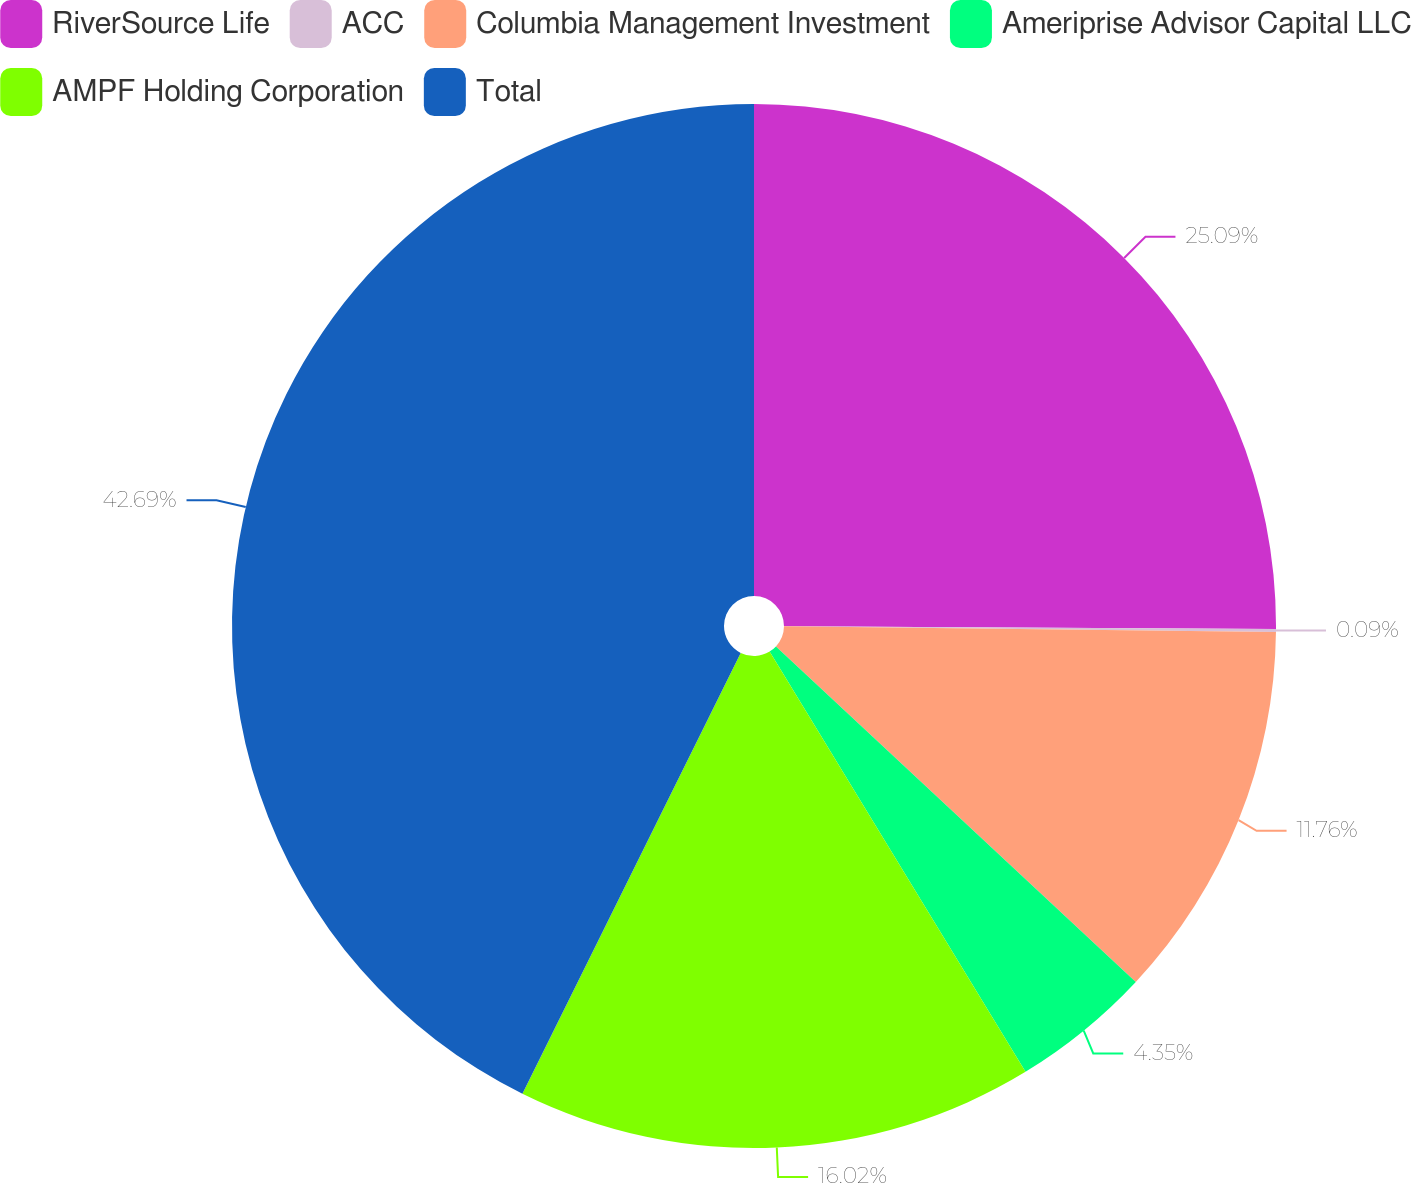Convert chart to OTSL. <chart><loc_0><loc_0><loc_500><loc_500><pie_chart><fcel>RiverSource Life<fcel>ACC<fcel>Columbia Management Investment<fcel>Ameriprise Advisor Capital LLC<fcel>AMPF Holding Corporation<fcel>Total<nl><fcel>25.09%<fcel>0.09%<fcel>11.76%<fcel>4.35%<fcel>16.02%<fcel>42.68%<nl></chart> 